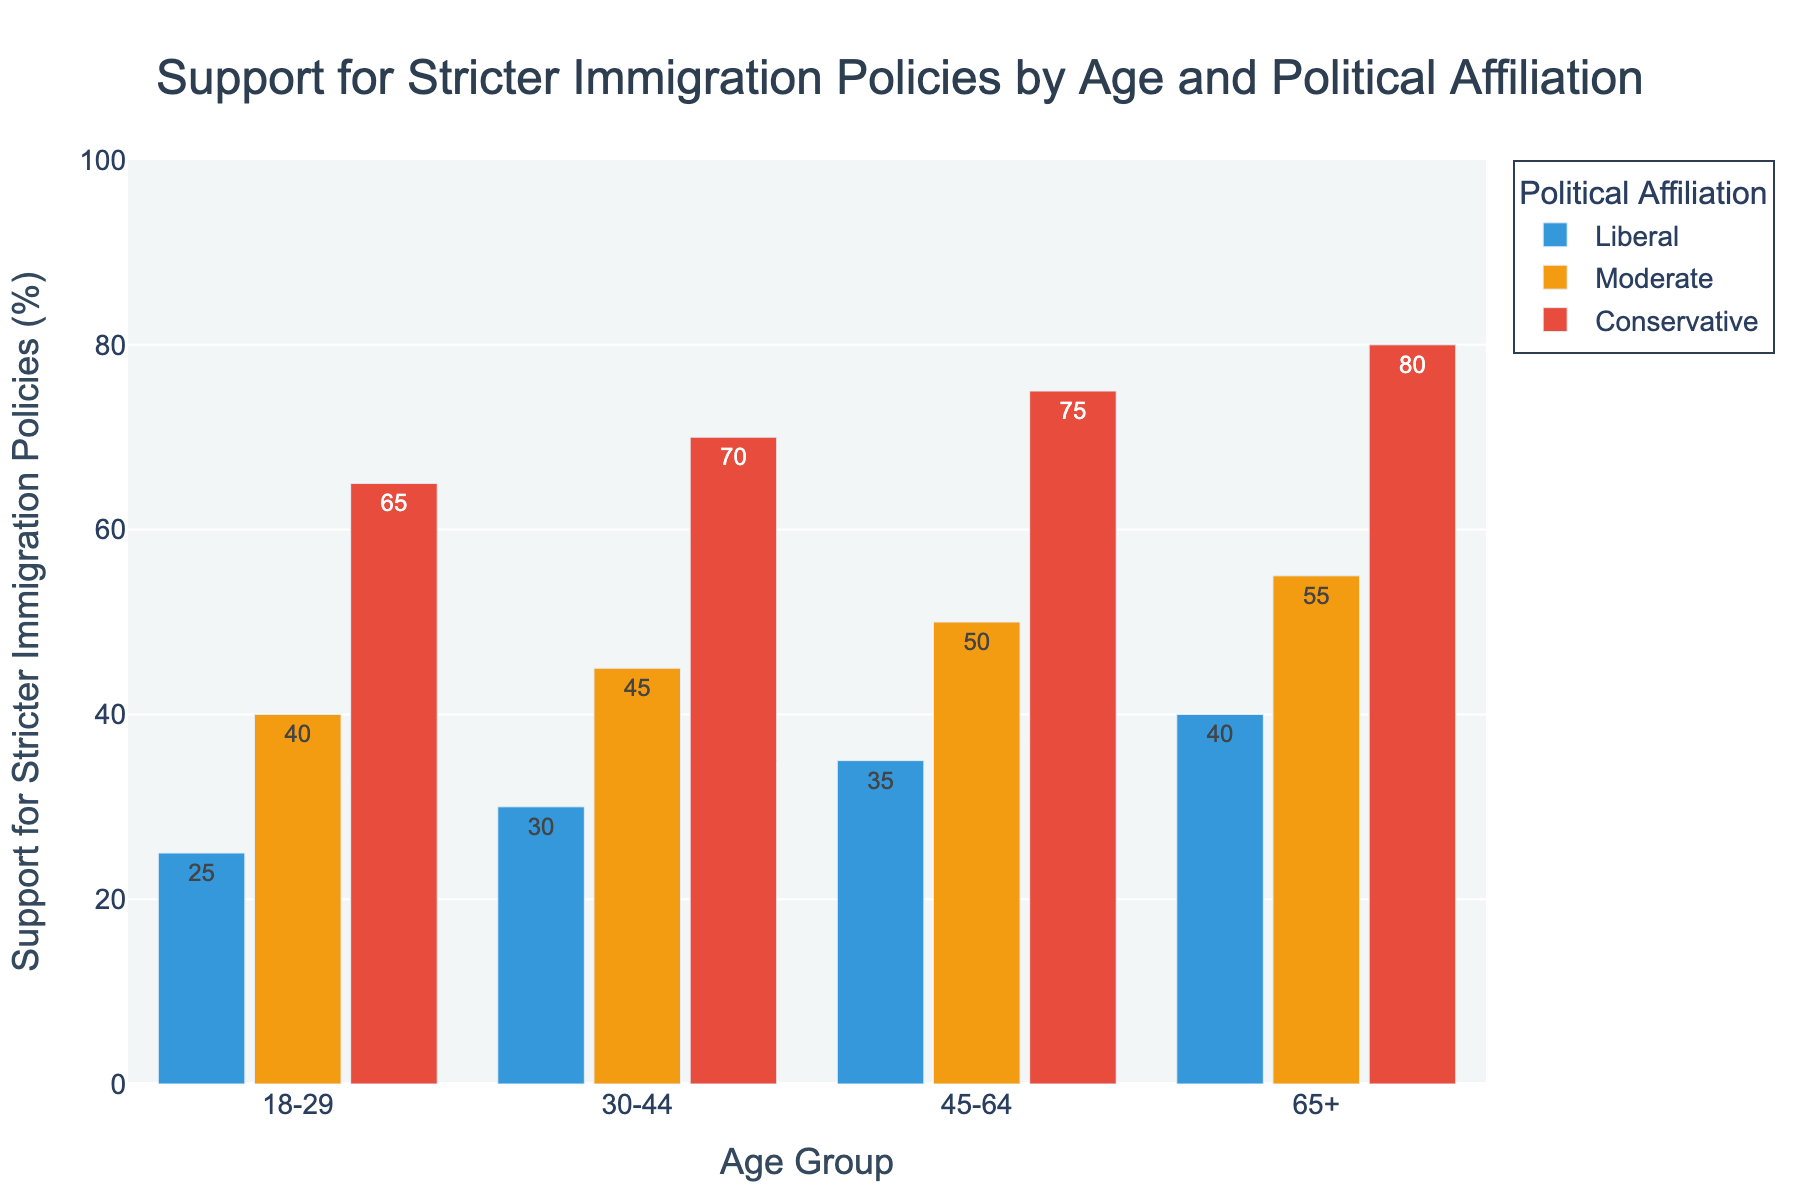What's the difference in support for stricter immigration policies between Conservative and Liberal affiliations in the 45-64 age group? From the chart, Conservative support in the 45-64 age group is 75% and Liberal support is 35%. The difference is 75% - 35% = 40%.
Answer: 40% Which age group shows the highest support for stricter immigration policies among Moderates? Looking at the chart, the support levels for Moderates are 40% (18-29), 45% (30-44), 50% (45-64), and 55% (65+). The highest support is in the 65+ age group with 55%.
Answer: 65+ What is the average support for stricter immigration policies among all age groups for Liberals? Liberal support percentages are 25% (18-29), 30% (30-44), 35% (45-64), and 40% (65+). Calculating the average: (25% + 30% + 35% + 40%) / 4 = 130% / 4 = 32.5%.
Answer: 32.5% Which political affiliation shows the least variation in support for stricter immigration policies across age groups? By comparing the support levels across age groups, the variations are as follows: Liberals (25%, 30%, 35%, 40%) vary from 25% to 40%, Moderates (40%, 45%, 50%, 55%) vary from 40% to 55%, and Conservatives (65%, 70%, 75%, 80%) vary from 65% to 80%. The smallest range is for Liberals.
Answer: Liberal How does the support for stricter immigration policies in the 18-29 age group compare between Conservatives and Moderates? In the 18-29 age group, Conservative support is 65% and Moderate support is 40%. Comparing these, Conservative support is higher by 65% - 40% = 25%.
Answer: 25% higher What is the combined support for stricter immigration policies among Conservatives in all age groups? The support levels are 65% (18-29), 70% (30-44), 75% (45-64), and 80% (65+). Adding these: 65% + 70% + 75% + 80% = 290%.
Answer: 290% Which age group shows the smallest increase in support for stricter immigration policies from Liberals to Conservatives? The increases are as follows: 18-29 (65% - 25% = 40%), 30-44 (70% - 30% = 40%), 45-64 (75% - 35% = 40%), and 65+ (80% - 40% = 40%). All age groups show the same increase of 40%.
Answer: All age groups show the same increase What is the median support for stricter immigration policies for each political affiliation across all age groups? For Liberals: sorted values (25%, 30%, 35%, 40%), median (30%+35%)/2 = 32.5%. For Moderates: sorted values (40%, 45%, 50%, 55%), median (45%+50%)/2 = 47.5%. For Conservatives: sorted values (65%, 70%, 75%, 80%), median (70%+75%)/2 = 72.5%.
Answer: Liberals: 32.5%, Moderates: 47.5%, Conservatives: 72.5% 